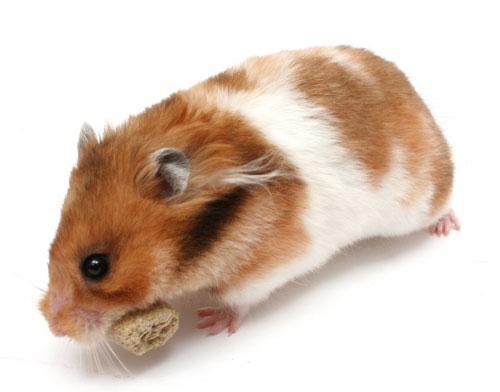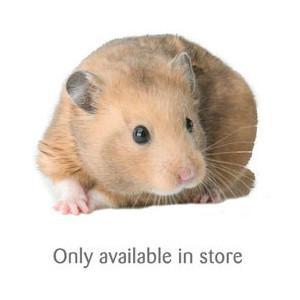The first image is the image on the left, the second image is the image on the right. For the images shown, is this caption "In one of the images there are two hamsters." true? Answer yes or no. No. 